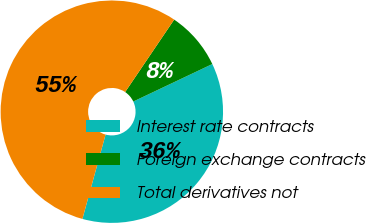Convert chart to OTSL. <chart><loc_0><loc_0><loc_500><loc_500><pie_chart><fcel>Interest rate contracts<fcel>Foreign exchange contracts<fcel>Total derivatives not<nl><fcel>36.31%<fcel>8.48%<fcel>55.2%<nl></chart> 